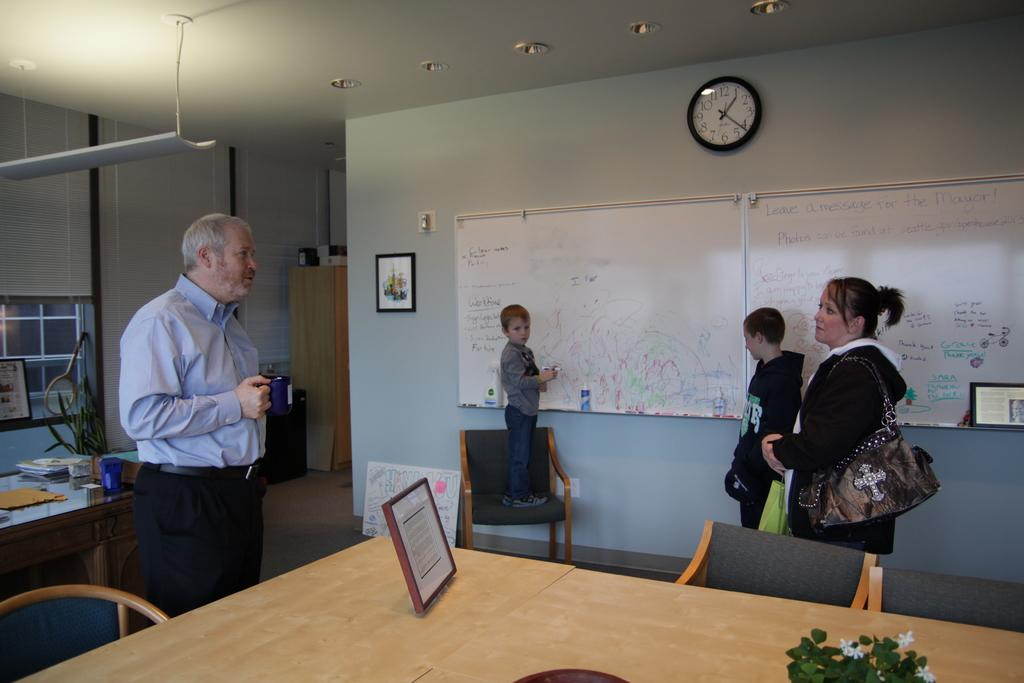What is happening in the room in the image? There are people standing in the room. What can be seen on the wall in the image? There is a notice board and a clock on the wall. What furniture is present in the room? There is a table in the room. What is placed on the table in the image? There is a photo frame on the table. Where is the tray located in the image? There is no tray present in the image. What type of brake can be seen on the wall in the image? There is no brake present in the image; only a notice board and a clock are on the wall. 